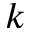Convert formula to latex. <formula><loc_0><loc_0><loc_500><loc_500>k</formula> 